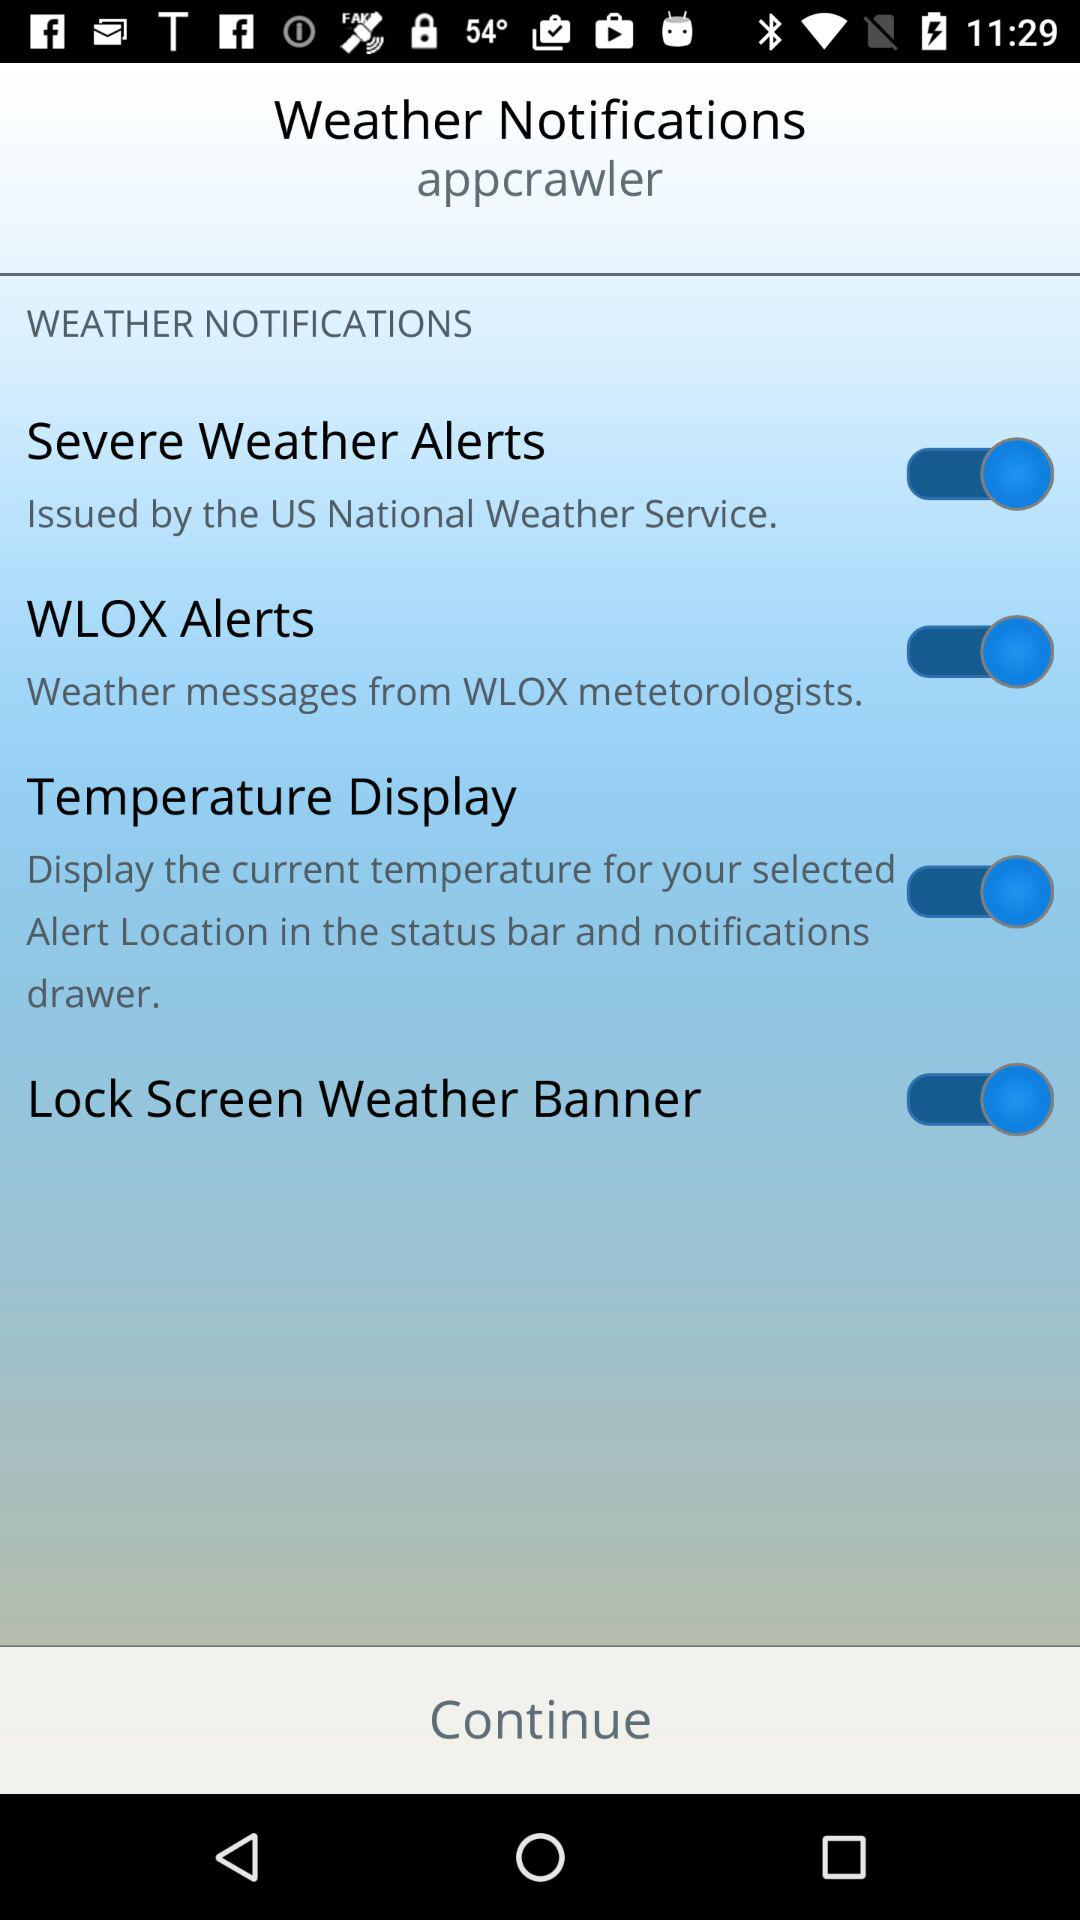What's the status of WLOX alerts? The status is on. 